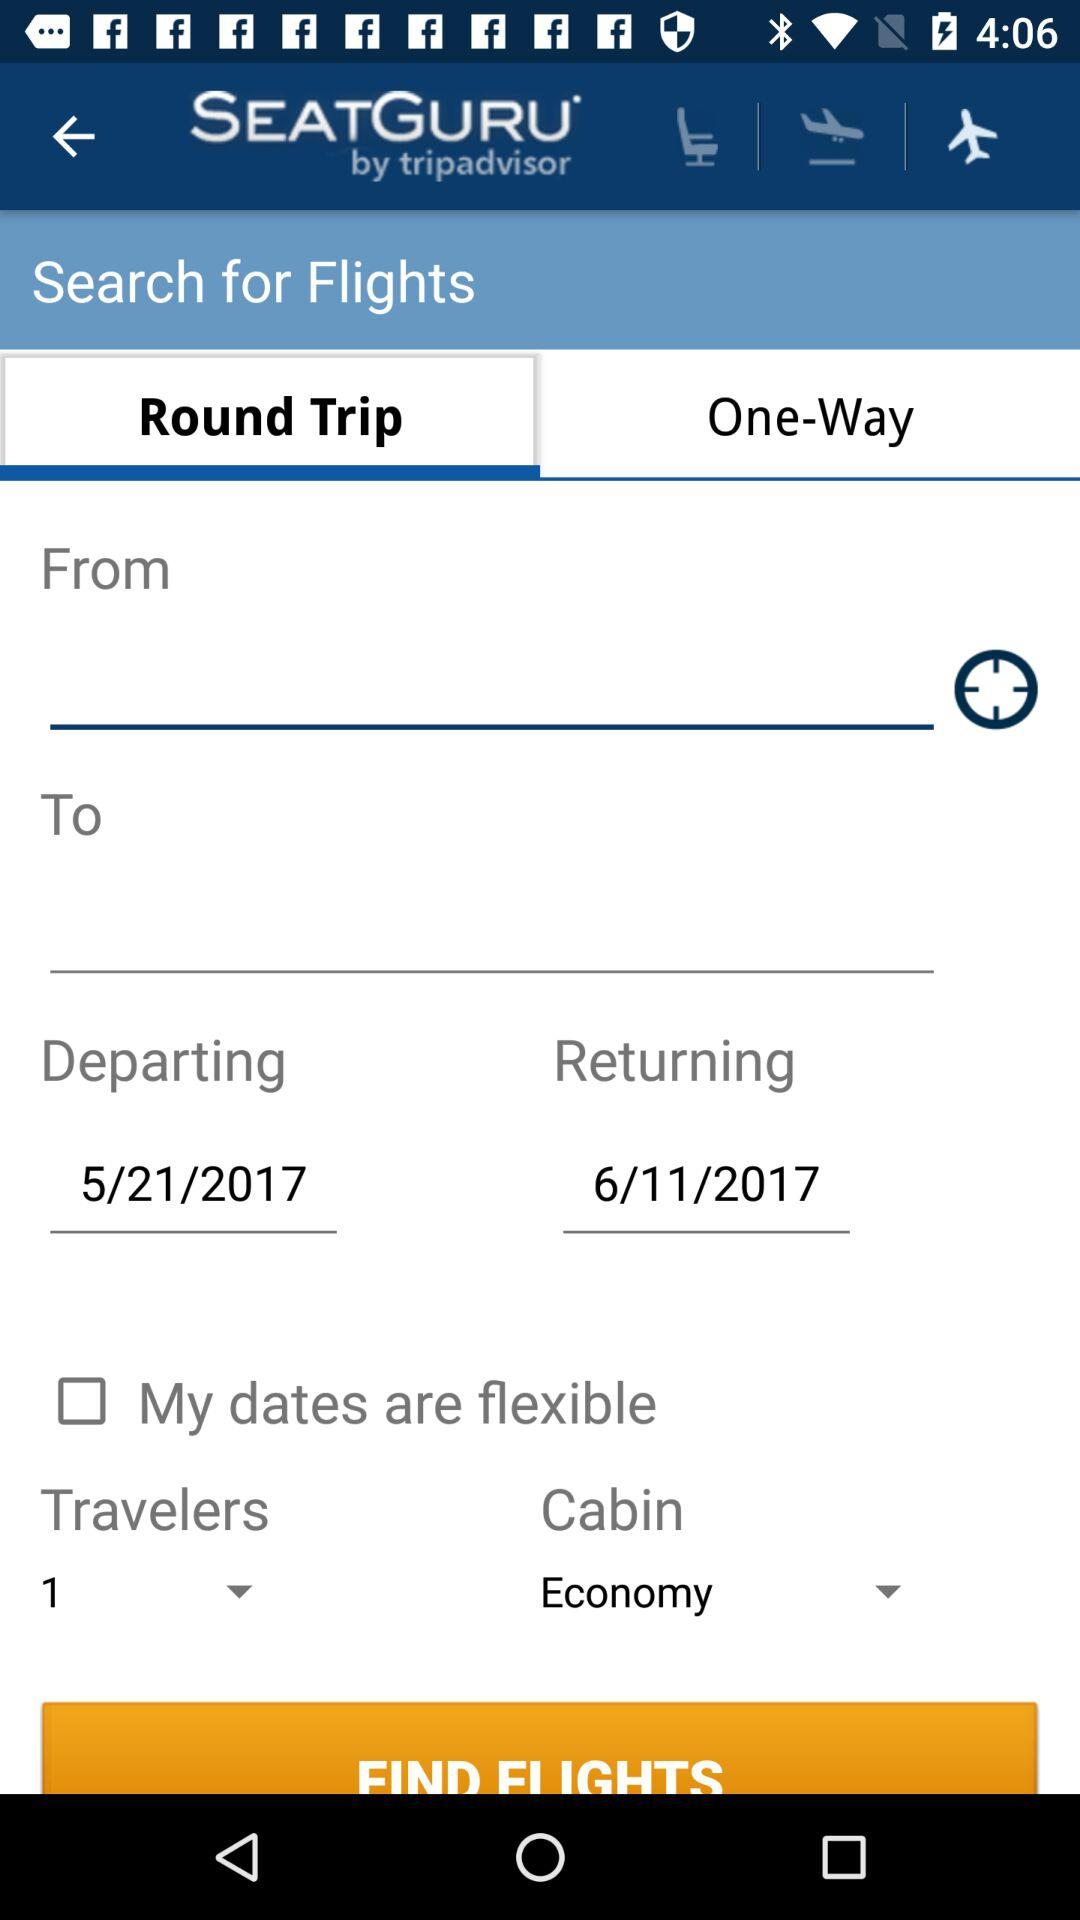What is the departing date? The departing date is May 21, 2017. 